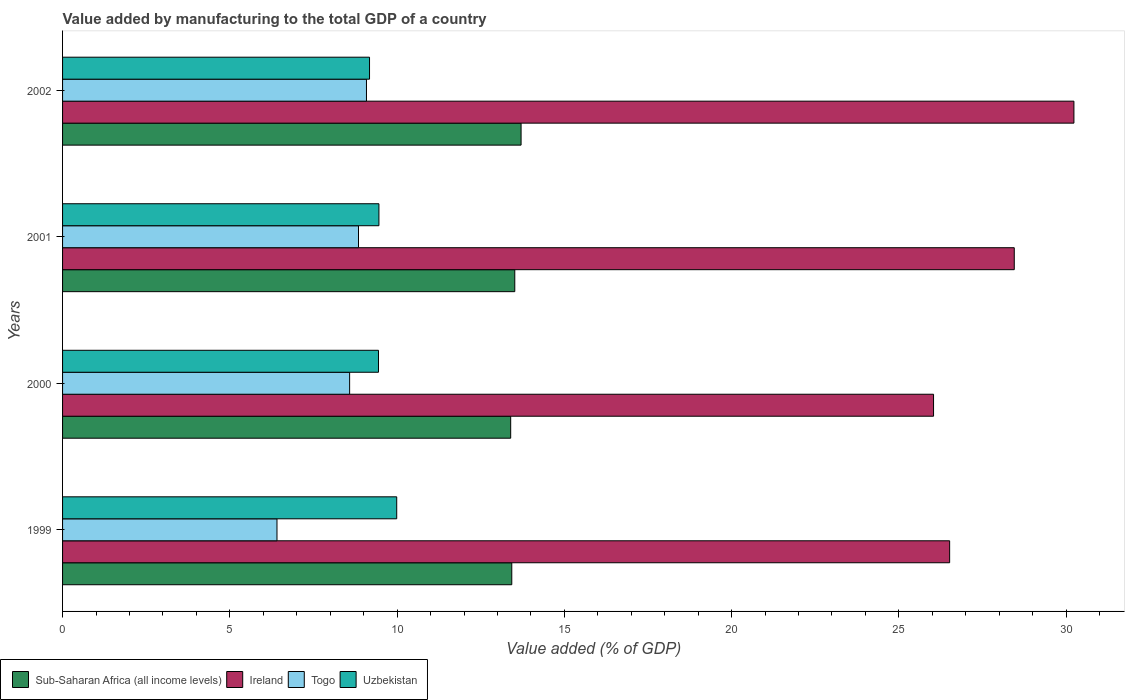How many different coloured bars are there?
Your response must be concise. 4. Are the number of bars per tick equal to the number of legend labels?
Provide a succinct answer. Yes. How many bars are there on the 1st tick from the top?
Give a very brief answer. 4. What is the label of the 2nd group of bars from the top?
Provide a short and direct response. 2001. What is the value added by manufacturing to the total GDP in Togo in 1999?
Your answer should be compact. 6.41. Across all years, what is the maximum value added by manufacturing to the total GDP in Togo?
Give a very brief answer. 9.08. Across all years, what is the minimum value added by manufacturing to the total GDP in Ireland?
Ensure brevity in your answer.  26.04. In which year was the value added by manufacturing to the total GDP in Togo maximum?
Offer a terse response. 2002. In which year was the value added by manufacturing to the total GDP in Uzbekistan minimum?
Offer a terse response. 2002. What is the total value added by manufacturing to the total GDP in Togo in the graph?
Your answer should be very brief. 32.92. What is the difference between the value added by manufacturing to the total GDP in Ireland in 2000 and that in 2001?
Your answer should be compact. -2.41. What is the difference between the value added by manufacturing to the total GDP in Uzbekistan in 2001 and the value added by manufacturing to the total GDP in Sub-Saharan Africa (all income levels) in 2002?
Provide a short and direct response. -4.25. What is the average value added by manufacturing to the total GDP in Sub-Saharan Africa (all income levels) per year?
Ensure brevity in your answer.  13.51. In the year 2000, what is the difference between the value added by manufacturing to the total GDP in Togo and value added by manufacturing to the total GDP in Sub-Saharan Africa (all income levels)?
Offer a very short reply. -4.81. What is the ratio of the value added by manufacturing to the total GDP in Sub-Saharan Africa (all income levels) in 1999 to that in 2000?
Ensure brevity in your answer.  1. Is the value added by manufacturing to the total GDP in Uzbekistan in 1999 less than that in 2002?
Ensure brevity in your answer.  No. Is the difference between the value added by manufacturing to the total GDP in Togo in 1999 and 2001 greater than the difference between the value added by manufacturing to the total GDP in Sub-Saharan Africa (all income levels) in 1999 and 2001?
Keep it short and to the point. No. What is the difference between the highest and the second highest value added by manufacturing to the total GDP in Togo?
Ensure brevity in your answer.  0.24. What is the difference between the highest and the lowest value added by manufacturing to the total GDP in Togo?
Make the answer very short. 2.67. Is it the case that in every year, the sum of the value added by manufacturing to the total GDP in Ireland and value added by manufacturing to the total GDP in Uzbekistan is greater than the sum of value added by manufacturing to the total GDP in Sub-Saharan Africa (all income levels) and value added by manufacturing to the total GDP in Togo?
Keep it short and to the point. Yes. What does the 3rd bar from the top in 1999 represents?
Offer a terse response. Ireland. What does the 4th bar from the bottom in 1999 represents?
Provide a succinct answer. Uzbekistan. How many bars are there?
Your answer should be compact. 16. How many years are there in the graph?
Provide a short and direct response. 4. What is the difference between two consecutive major ticks on the X-axis?
Your response must be concise. 5. Are the values on the major ticks of X-axis written in scientific E-notation?
Provide a short and direct response. No. Does the graph contain grids?
Your response must be concise. No. Where does the legend appear in the graph?
Ensure brevity in your answer.  Bottom left. How many legend labels are there?
Give a very brief answer. 4. What is the title of the graph?
Provide a short and direct response. Value added by manufacturing to the total GDP of a country. What is the label or title of the X-axis?
Your answer should be compact. Value added (% of GDP). What is the label or title of the Y-axis?
Give a very brief answer. Years. What is the Value added (% of GDP) in Sub-Saharan Africa (all income levels) in 1999?
Ensure brevity in your answer.  13.43. What is the Value added (% of GDP) in Ireland in 1999?
Provide a succinct answer. 26.52. What is the Value added (% of GDP) of Togo in 1999?
Your answer should be compact. 6.41. What is the Value added (% of GDP) of Uzbekistan in 1999?
Provide a short and direct response. 9.99. What is the Value added (% of GDP) of Sub-Saharan Africa (all income levels) in 2000?
Make the answer very short. 13.4. What is the Value added (% of GDP) of Ireland in 2000?
Your answer should be very brief. 26.04. What is the Value added (% of GDP) of Togo in 2000?
Your answer should be compact. 8.58. What is the Value added (% of GDP) in Uzbekistan in 2000?
Ensure brevity in your answer.  9.44. What is the Value added (% of GDP) in Sub-Saharan Africa (all income levels) in 2001?
Your answer should be very brief. 13.52. What is the Value added (% of GDP) of Ireland in 2001?
Your answer should be compact. 28.45. What is the Value added (% of GDP) of Togo in 2001?
Keep it short and to the point. 8.85. What is the Value added (% of GDP) of Uzbekistan in 2001?
Your answer should be very brief. 9.46. What is the Value added (% of GDP) of Sub-Saharan Africa (all income levels) in 2002?
Keep it short and to the point. 13.71. What is the Value added (% of GDP) of Ireland in 2002?
Ensure brevity in your answer.  30.23. What is the Value added (% of GDP) of Togo in 2002?
Your answer should be very brief. 9.08. What is the Value added (% of GDP) of Uzbekistan in 2002?
Your response must be concise. 9.18. Across all years, what is the maximum Value added (% of GDP) of Sub-Saharan Africa (all income levels)?
Make the answer very short. 13.71. Across all years, what is the maximum Value added (% of GDP) of Ireland?
Provide a succinct answer. 30.23. Across all years, what is the maximum Value added (% of GDP) in Togo?
Make the answer very short. 9.08. Across all years, what is the maximum Value added (% of GDP) of Uzbekistan?
Keep it short and to the point. 9.99. Across all years, what is the minimum Value added (% of GDP) of Sub-Saharan Africa (all income levels)?
Make the answer very short. 13.4. Across all years, what is the minimum Value added (% of GDP) of Ireland?
Provide a succinct answer. 26.04. Across all years, what is the minimum Value added (% of GDP) of Togo?
Provide a succinct answer. 6.41. Across all years, what is the minimum Value added (% of GDP) in Uzbekistan?
Provide a short and direct response. 9.18. What is the total Value added (% of GDP) in Sub-Saharan Africa (all income levels) in the graph?
Provide a short and direct response. 54.05. What is the total Value added (% of GDP) of Ireland in the graph?
Ensure brevity in your answer.  111.24. What is the total Value added (% of GDP) of Togo in the graph?
Offer a very short reply. 32.92. What is the total Value added (% of GDP) in Uzbekistan in the graph?
Your response must be concise. 38.07. What is the difference between the Value added (% of GDP) in Sub-Saharan Africa (all income levels) in 1999 and that in 2000?
Provide a short and direct response. 0.03. What is the difference between the Value added (% of GDP) of Ireland in 1999 and that in 2000?
Your answer should be very brief. 0.48. What is the difference between the Value added (% of GDP) in Togo in 1999 and that in 2000?
Your answer should be compact. -2.17. What is the difference between the Value added (% of GDP) in Uzbekistan in 1999 and that in 2000?
Give a very brief answer. 0.55. What is the difference between the Value added (% of GDP) of Sub-Saharan Africa (all income levels) in 1999 and that in 2001?
Give a very brief answer. -0.09. What is the difference between the Value added (% of GDP) in Ireland in 1999 and that in 2001?
Your answer should be compact. -1.93. What is the difference between the Value added (% of GDP) of Togo in 1999 and that in 2001?
Your answer should be compact. -2.44. What is the difference between the Value added (% of GDP) of Uzbekistan in 1999 and that in 2001?
Your answer should be very brief. 0.53. What is the difference between the Value added (% of GDP) of Sub-Saharan Africa (all income levels) in 1999 and that in 2002?
Keep it short and to the point. -0.28. What is the difference between the Value added (% of GDP) in Ireland in 1999 and that in 2002?
Provide a succinct answer. -3.72. What is the difference between the Value added (% of GDP) of Togo in 1999 and that in 2002?
Provide a short and direct response. -2.67. What is the difference between the Value added (% of GDP) of Uzbekistan in 1999 and that in 2002?
Your answer should be very brief. 0.81. What is the difference between the Value added (% of GDP) in Sub-Saharan Africa (all income levels) in 2000 and that in 2001?
Provide a short and direct response. -0.12. What is the difference between the Value added (% of GDP) in Ireland in 2000 and that in 2001?
Give a very brief answer. -2.41. What is the difference between the Value added (% of GDP) of Togo in 2000 and that in 2001?
Provide a succinct answer. -0.27. What is the difference between the Value added (% of GDP) in Uzbekistan in 2000 and that in 2001?
Your response must be concise. -0.01. What is the difference between the Value added (% of GDP) in Sub-Saharan Africa (all income levels) in 2000 and that in 2002?
Provide a short and direct response. -0.31. What is the difference between the Value added (% of GDP) in Ireland in 2000 and that in 2002?
Give a very brief answer. -4.2. What is the difference between the Value added (% of GDP) of Togo in 2000 and that in 2002?
Ensure brevity in your answer.  -0.5. What is the difference between the Value added (% of GDP) of Uzbekistan in 2000 and that in 2002?
Keep it short and to the point. 0.27. What is the difference between the Value added (% of GDP) in Sub-Saharan Africa (all income levels) in 2001 and that in 2002?
Offer a very short reply. -0.19. What is the difference between the Value added (% of GDP) of Ireland in 2001 and that in 2002?
Your response must be concise. -1.78. What is the difference between the Value added (% of GDP) in Togo in 2001 and that in 2002?
Provide a succinct answer. -0.24. What is the difference between the Value added (% of GDP) of Uzbekistan in 2001 and that in 2002?
Keep it short and to the point. 0.28. What is the difference between the Value added (% of GDP) in Sub-Saharan Africa (all income levels) in 1999 and the Value added (% of GDP) in Ireland in 2000?
Keep it short and to the point. -12.61. What is the difference between the Value added (% of GDP) of Sub-Saharan Africa (all income levels) in 1999 and the Value added (% of GDP) of Togo in 2000?
Provide a short and direct response. 4.85. What is the difference between the Value added (% of GDP) in Sub-Saharan Africa (all income levels) in 1999 and the Value added (% of GDP) in Uzbekistan in 2000?
Give a very brief answer. 3.98. What is the difference between the Value added (% of GDP) of Ireland in 1999 and the Value added (% of GDP) of Togo in 2000?
Ensure brevity in your answer.  17.94. What is the difference between the Value added (% of GDP) in Ireland in 1999 and the Value added (% of GDP) in Uzbekistan in 2000?
Ensure brevity in your answer.  17.07. What is the difference between the Value added (% of GDP) of Togo in 1999 and the Value added (% of GDP) of Uzbekistan in 2000?
Make the answer very short. -3.03. What is the difference between the Value added (% of GDP) in Sub-Saharan Africa (all income levels) in 1999 and the Value added (% of GDP) in Ireland in 2001?
Provide a succinct answer. -15.02. What is the difference between the Value added (% of GDP) of Sub-Saharan Africa (all income levels) in 1999 and the Value added (% of GDP) of Togo in 2001?
Provide a short and direct response. 4.58. What is the difference between the Value added (% of GDP) in Sub-Saharan Africa (all income levels) in 1999 and the Value added (% of GDP) in Uzbekistan in 2001?
Give a very brief answer. 3.97. What is the difference between the Value added (% of GDP) of Ireland in 1999 and the Value added (% of GDP) of Togo in 2001?
Offer a very short reply. 17.67. What is the difference between the Value added (% of GDP) in Ireland in 1999 and the Value added (% of GDP) in Uzbekistan in 2001?
Keep it short and to the point. 17.06. What is the difference between the Value added (% of GDP) of Togo in 1999 and the Value added (% of GDP) of Uzbekistan in 2001?
Offer a terse response. -3.05. What is the difference between the Value added (% of GDP) of Sub-Saharan Africa (all income levels) in 1999 and the Value added (% of GDP) of Ireland in 2002?
Your answer should be very brief. -16.8. What is the difference between the Value added (% of GDP) in Sub-Saharan Africa (all income levels) in 1999 and the Value added (% of GDP) in Togo in 2002?
Offer a very short reply. 4.34. What is the difference between the Value added (% of GDP) in Sub-Saharan Africa (all income levels) in 1999 and the Value added (% of GDP) in Uzbekistan in 2002?
Provide a succinct answer. 4.25. What is the difference between the Value added (% of GDP) in Ireland in 1999 and the Value added (% of GDP) in Togo in 2002?
Offer a very short reply. 17.43. What is the difference between the Value added (% of GDP) in Ireland in 1999 and the Value added (% of GDP) in Uzbekistan in 2002?
Provide a succinct answer. 17.34. What is the difference between the Value added (% of GDP) of Togo in 1999 and the Value added (% of GDP) of Uzbekistan in 2002?
Give a very brief answer. -2.77. What is the difference between the Value added (% of GDP) in Sub-Saharan Africa (all income levels) in 2000 and the Value added (% of GDP) in Ireland in 2001?
Your response must be concise. -15.05. What is the difference between the Value added (% of GDP) in Sub-Saharan Africa (all income levels) in 2000 and the Value added (% of GDP) in Togo in 2001?
Make the answer very short. 4.55. What is the difference between the Value added (% of GDP) of Sub-Saharan Africa (all income levels) in 2000 and the Value added (% of GDP) of Uzbekistan in 2001?
Give a very brief answer. 3.94. What is the difference between the Value added (% of GDP) in Ireland in 2000 and the Value added (% of GDP) in Togo in 2001?
Offer a terse response. 17.19. What is the difference between the Value added (% of GDP) of Ireland in 2000 and the Value added (% of GDP) of Uzbekistan in 2001?
Your answer should be very brief. 16.58. What is the difference between the Value added (% of GDP) in Togo in 2000 and the Value added (% of GDP) in Uzbekistan in 2001?
Give a very brief answer. -0.88. What is the difference between the Value added (% of GDP) in Sub-Saharan Africa (all income levels) in 2000 and the Value added (% of GDP) in Ireland in 2002?
Give a very brief answer. -16.84. What is the difference between the Value added (% of GDP) in Sub-Saharan Africa (all income levels) in 2000 and the Value added (% of GDP) in Togo in 2002?
Offer a very short reply. 4.31. What is the difference between the Value added (% of GDP) of Sub-Saharan Africa (all income levels) in 2000 and the Value added (% of GDP) of Uzbekistan in 2002?
Offer a very short reply. 4.22. What is the difference between the Value added (% of GDP) in Ireland in 2000 and the Value added (% of GDP) in Togo in 2002?
Keep it short and to the point. 16.95. What is the difference between the Value added (% of GDP) in Ireland in 2000 and the Value added (% of GDP) in Uzbekistan in 2002?
Offer a very short reply. 16.86. What is the difference between the Value added (% of GDP) of Togo in 2000 and the Value added (% of GDP) of Uzbekistan in 2002?
Make the answer very short. -0.59. What is the difference between the Value added (% of GDP) in Sub-Saharan Africa (all income levels) in 2001 and the Value added (% of GDP) in Ireland in 2002?
Offer a very short reply. -16.71. What is the difference between the Value added (% of GDP) of Sub-Saharan Africa (all income levels) in 2001 and the Value added (% of GDP) of Togo in 2002?
Provide a short and direct response. 4.43. What is the difference between the Value added (% of GDP) of Sub-Saharan Africa (all income levels) in 2001 and the Value added (% of GDP) of Uzbekistan in 2002?
Provide a short and direct response. 4.34. What is the difference between the Value added (% of GDP) of Ireland in 2001 and the Value added (% of GDP) of Togo in 2002?
Provide a short and direct response. 19.36. What is the difference between the Value added (% of GDP) of Ireland in 2001 and the Value added (% of GDP) of Uzbekistan in 2002?
Offer a terse response. 19.27. What is the difference between the Value added (% of GDP) of Togo in 2001 and the Value added (% of GDP) of Uzbekistan in 2002?
Your answer should be very brief. -0.33. What is the average Value added (% of GDP) in Sub-Saharan Africa (all income levels) per year?
Make the answer very short. 13.51. What is the average Value added (% of GDP) of Ireland per year?
Provide a short and direct response. 27.81. What is the average Value added (% of GDP) in Togo per year?
Make the answer very short. 8.23. What is the average Value added (% of GDP) of Uzbekistan per year?
Offer a very short reply. 9.52. In the year 1999, what is the difference between the Value added (% of GDP) of Sub-Saharan Africa (all income levels) and Value added (% of GDP) of Ireland?
Keep it short and to the point. -13.09. In the year 1999, what is the difference between the Value added (% of GDP) of Sub-Saharan Africa (all income levels) and Value added (% of GDP) of Togo?
Offer a terse response. 7.02. In the year 1999, what is the difference between the Value added (% of GDP) of Sub-Saharan Africa (all income levels) and Value added (% of GDP) of Uzbekistan?
Make the answer very short. 3.44. In the year 1999, what is the difference between the Value added (% of GDP) in Ireland and Value added (% of GDP) in Togo?
Your answer should be compact. 20.11. In the year 1999, what is the difference between the Value added (% of GDP) of Ireland and Value added (% of GDP) of Uzbekistan?
Offer a very short reply. 16.53. In the year 1999, what is the difference between the Value added (% of GDP) in Togo and Value added (% of GDP) in Uzbekistan?
Your answer should be very brief. -3.58. In the year 2000, what is the difference between the Value added (% of GDP) of Sub-Saharan Africa (all income levels) and Value added (% of GDP) of Ireland?
Offer a very short reply. -12.64. In the year 2000, what is the difference between the Value added (% of GDP) of Sub-Saharan Africa (all income levels) and Value added (% of GDP) of Togo?
Give a very brief answer. 4.81. In the year 2000, what is the difference between the Value added (% of GDP) of Sub-Saharan Africa (all income levels) and Value added (% of GDP) of Uzbekistan?
Your answer should be very brief. 3.95. In the year 2000, what is the difference between the Value added (% of GDP) in Ireland and Value added (% of GDP) in Togo?
Give a very brief answer. 17.45. In the year 2000, what is the difference between the Value added (% of GDP) in Ireland and Value added (% of GDP) in Uzbekistan?
Keep it short and to the point. 16.59. In the year 2000, what is the difference between the Value added (% of GDP) in Togo and Value added (% of GDP) in Uzbekistan?
Provide a short and direct response. -0.86. In the year 2001, what is the difference between the Value added (% of GDP) in Sub-Saharan Africa (all income levels) and Value added (% of GDP) in Ireland?
Provide a short and direct response. -14.93. In the year 2001, what is the difference between the Value added (% of GDP) in Sub-Saharan Africa (all income levels) and Value added (% of GDP) in Togo?
Offer a terse response. 4.67. In the year 2001, what is the difference between the Value added (% of GDP) of Sub-Saharan Africa (all income levels) and Value added (% of GDP) of Uzbekistan?
Keep it short and to the point. 4.06. In the year 2001, what is the difference between the Value added (% of GDP) in Ireland and Value added (% of GDP) in Togo?
Make the answer very short. 19.6. In the year 2001, what is the difference between the Value added (% of GDP) of Ireland and Value added (% of GDP) of Uzbekistan?
Your answer should be compact. 18.99. In the year 2001, what is the difference between the Value added (% of GDP) in Togo and Value added (% of GDP) in Uzbekistan?
Provide a short and direct response. -0.61. In the year 2002, what is the difference between the Value added (% of GDP) in Sub-Saharan Africa (all income levels) and Value added (% of GDP) in Ireland?
Ensure brevity in your answer.  -16.53. In the year 2002, what is the difference between the Value added (% of GDP) in Sub-Saharan Africa (all income levels) and Value added (% of GDP) in Togo?
Offer a terse response. 4.62. In the year 2002, what is the difference between the Value added (% of GDP) of Sub-Saharan Africa (all income levels) and Value added (% of GDP) of Uzbekistan?
Keep it short and to the point. 4.53. In the year 2002, what is the difference between the Value added (% of GDP) in Ireland and Value added (% of GDP) in Togo?
Make the answer very short. 21.15. In the year 2002, what is the difference between the Value added (% of GDP) in Ireland and Value added (% of GDP) in Uzbekistan?
Keep it short and to the point. 21.06. In the year 2002, what is the difference between the Value added (% of GDP) of Togo and Value added (% of GDP) of Uzbekistan?
Offer a very short reply. -0.09. What is the ratio of the Value added (% of GDP) in Ireland in 1999 to that in 2000?
Offer a very short reply. 1.02. What is the ratio of the Value added (% of GDP) of Togo in 1999 to that in 2000?
Provide a succinct answer. 0.75. What is the ratio of the Value added (% of GDP) in Uzbekistan in 1999 to that in 2000?
Your answer should be compact. 1.06. What is the ratio of the Value added (% of GDP) in Sub-Saharan Africa (all income levels) in 1999 to that in 2001?
Offer a very short reply. 0.99. What is the ratio of the Value added (% of GDP) in Ireland in 1999 to that in 2001?
Your answer should be compact. 0.93. What is the ratio of the Value added (% of GDP) of Togo in 1999 to that in 2001?
Offer a very short reply. 0.72. What is the ratio of the Value added (% of GDP) of Uzbekistan in 1999 to that in 2001?
Give a very brief answer. 1.06. What is the ratio of the Value added (% of GDP) in Sub-Saharan Africa (all income levels) in 1999 to that in 2002?
Keep it short and to the point. 0.98. What is the ratio of the Value added (% of GDP) in Ireland in 1999 to that in 2002?
Your response must be concise. 0.88. What is the ratio of the Value added (% of GDP) of Togo in 1999 to that in 2002?
Give a very brief answer. 0.71. What is the ratio of the Value added (% of GDP) of Uzbekistan in 1999 to that in 2002?
Your answer should be compact. 1.09. What is the ratio of the Value added (% of GDP) in Sub-Saharan Africa (all income levels) in 2000 to that in 2001?
Offer a terse response. 0.99. What is the ratio of the Value added (% of GDP) of Ireland in 2000 to that in 2001?
Provide a succinct answer. 0.92. What is the ratio of the Value added (% of GDP) of Togo in 2000 to that in 2001?
Give a very brief answer. 0.97. What is the ratio of the Value added (% of GDP) of Uzbekistan in 2000 to that in 2001?
Keep it short and to the point. 1. What is the ratio of the Value added (% of GDP) of Sub-Saharan Africa (all income levels) in 2000 to that in 2002?
Make the answer very short. 0.98. What is the ratio of the Value added (% of GDP) of Ireland in 2000 to that in 2002?
Give a very brief answer. 0.86. What is the ratio of the Value added (% of GDP) in Togo in 2000 to that in 2002?
Provide a succinct answer. 0.94. What is the ratio of the Value added (% of GDP) in Uzbekistan in 2000 to that in 2002?
Your response must be concise. 1.03. What is the ratio of the Value added (% of GDP) of Sub-Saharan Africa (all income levels) in 2001 to that in 2002?
Make the answer very short. 0.99. What is the ratio of the Value added (% of GDP) in Ireland in 2001 to that in 2002?
Ensure brevity in your answer.  0.94. What is the ratio of the Value added (% of GDP) of Togo in 2001 to that in 2002?
Offer a terse response. 0.97. What is the ratio of the Value added (% of GDP) of Uzbekistan in 2001 to that in 2002?
Provide a succinct answer. 1.03. What is the difference between the highest and the second highest Value added (% of GDP) in Sub-Saharan Africa (all income levels)?
Offer a very short reply. 0.19. What is the difference between the highest and the second highest Value added (% of GDP) of Ireland?
Provide a short and direct response. 1.78. What is the difference between the highest and the second highest Value added (% of GDP) of Togo?
Your answer should be compact. 0.24. What is the difference between the highest and the second highest Value added (% of GDP) of Uzbekistan?
Offer a terse response. 0.53. What is the difference between the highest and the lowest Value added (% of GDP) in Sub-Saharan Africa (all income levels)?
Make the answer very short. 0.31. What is the difference between the highest and the lowest Value added (% of GDP) of Ireland?
Provide a short and direct response. 4.2. What is the difference between the highest and the lowest Value added (% of GDP) in Togo?
Make the answer very short. 2.67. What is the difference between the highest and the lowest Value added (% of GDP) in Uzbekistan?
Provide a short and direct response. 0.81. 